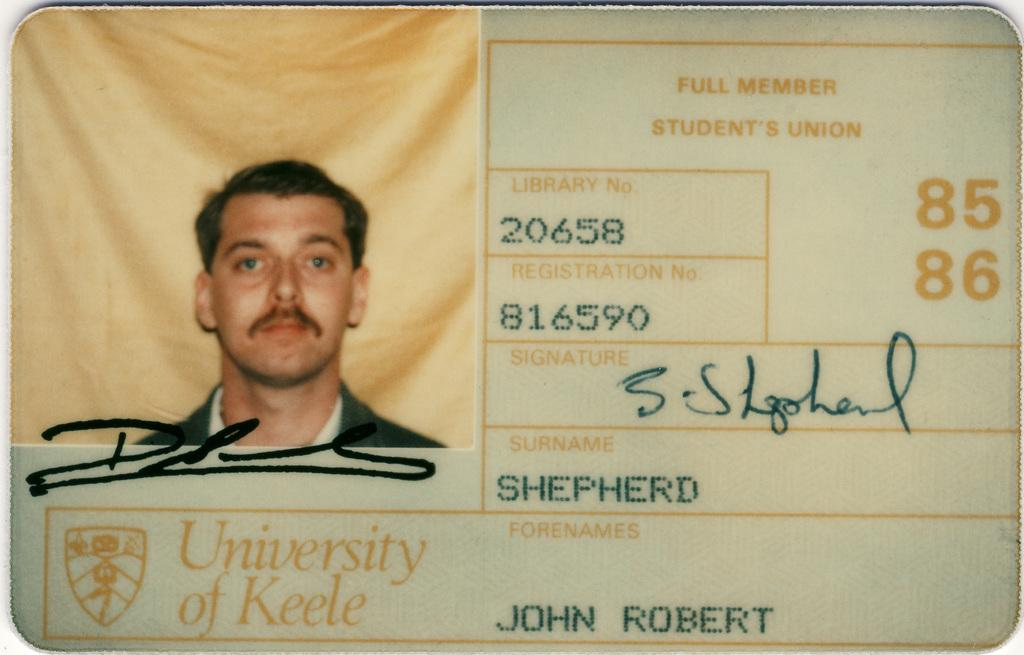What is the main object in the image? There is an ID card in the image. What can be seen on the ID card? There is a picture of a man on the ID card. Are there any words or numbers on the ID card? Yes, there is text on the ID card. What type of sticks can be seen in the picture on the ID card? There are no sticks visible in the image, as the main object is an ID card with a picture of a man and text. 